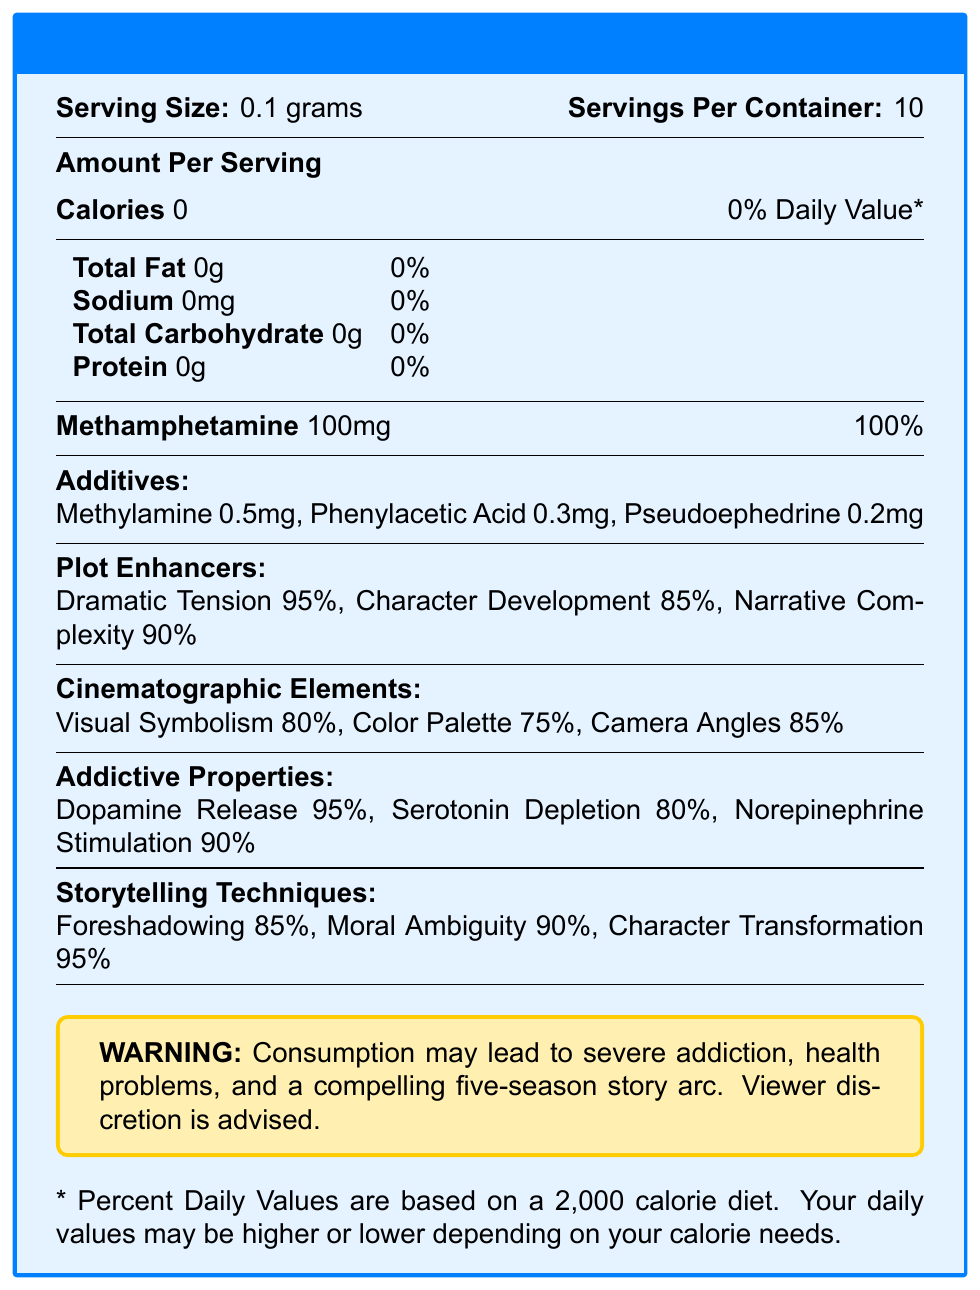how many servings are in the container? The document lists 10 servings per container.
Answer: 10 what is the serving size? The document indicates a serving size of 0.1 grams.
Answer: 0.1 grams how many calories are in each serving? According to the document, each serving contains 0 calories.
Answer: 0 what is the percentage of methamphetamine in one serving? The document states that each serving contains 100% methamphetamine.
Answer: 100% name two additives included in the blue meth. The additives section lists Methylamine, Phenylacetic Acid, and Pseudoephedrine.
Answer: Methylamine, Phenylacetic Acid what plot enhancer has the highest percentage? A. Dramatic Tension B. Character Development C. Narrative Complexity D. Foreshadowing The document indicates Dramatic Tension has the highest percentage at 95%.
Answer: A. Dramatic Tension which cinematographic element has the lowest percentage? 1. Visual Symbolism 2. Color Palette 3. Camera Angles The document shows Color Palette at 75%, which is the lowest among the cinematographic elements.
Answer: 2. Color Palette does the document list any dietary fat in the blue meth? The document indicates that Total Fat is 0 grams.
Answer: No summarize the main idea of the document. The document blends nutritional facts with elements of storytelling and cinematographic aspects to humorously depict the addictive and compelling nature of Breaking Bad's blue meth.
Answer: The document is a parody nutrition facts label for Walter White's blue meth featured in "Breaking Bad". It humorously lists the ingredients and adds fictitious elements like plot enhancers and cinematographic features, along with a warning about addiction. what is the percentage of serotonin depletion caused by the blue meth? The Addictive Properties section lists serotonin depletion at 80%.
Answer: 80% is sodium present in the blue meth according to the document? The document specifies that sodium content is 0mg.
Answer: No what value is associated with moral ambiguity in the storytelling techniques section? The storytelling techniques section lists moral ambiguity at 90%.
Answer: 90% what health problems does the document warn about? The warning box specifies these issues as potential risks.
Answer: Severe addiction, health problems, and a compelling five-season story arc who created the blue meth referred to in the document? The name "Walter White" is mentioned in the introduction, but the document itself does not explicitly state who created the blue meth.
Answer: Not enough information 